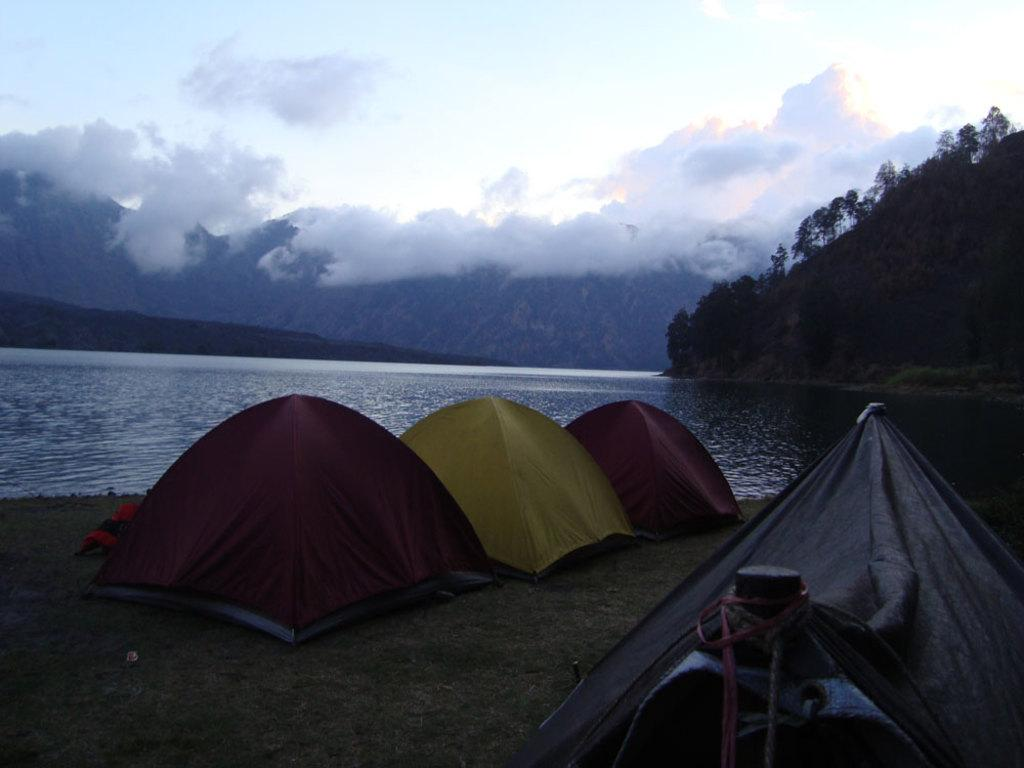What type of structures are located near the river in the image? There are tents near the river in the image. What can be seen on the right side of the image? There are many trees on the right side of the image. What is visible in the background of the image? Mountains are visible in the background of the image. What is visible at the top of the image? The sky is visible at the top of the image. What can be observed in the sky? Clouds are present in the sky. What type of polish is being applied to the birthday cake in the image? There is no birthday cake or polish present in the image. What riddle is being solved by the trees in the image? There is no riddle being solved by the trees in the image; they are simply trees. 